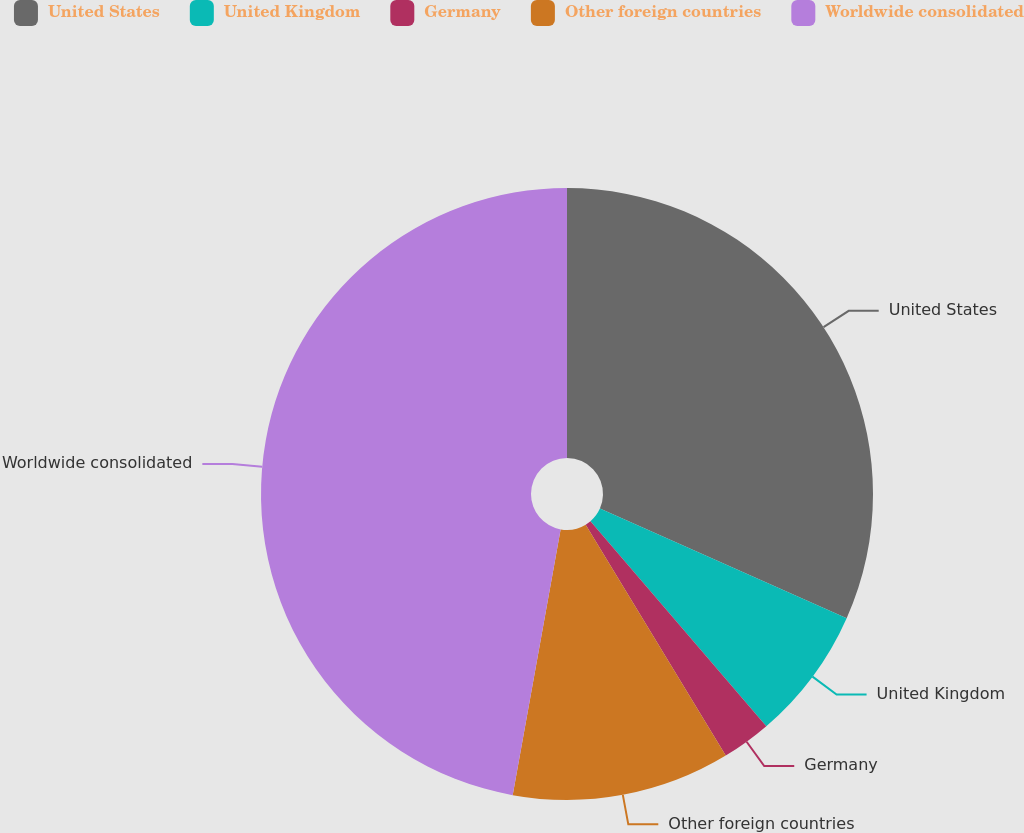Convert chart. <chart><loc_0><loc_0><loc_500><loc_500><pie_chart><fcel>United States<fcel>United Kingdom<fcel>Germany<fcel>Other foreign countries<fcel>Worldwide consolidated<nl><fcel>31.65%<fcel>7.06%<fcel>2.61%<fcel>11.52%<fcel>47.16%<nl></chart> 